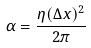<formula> <loc_0><loc_0><loc_500><loc_500>\alpha = \frac { \eta ( \Delta x ) ^ { 2 } } { 2 \pi }</formula> 